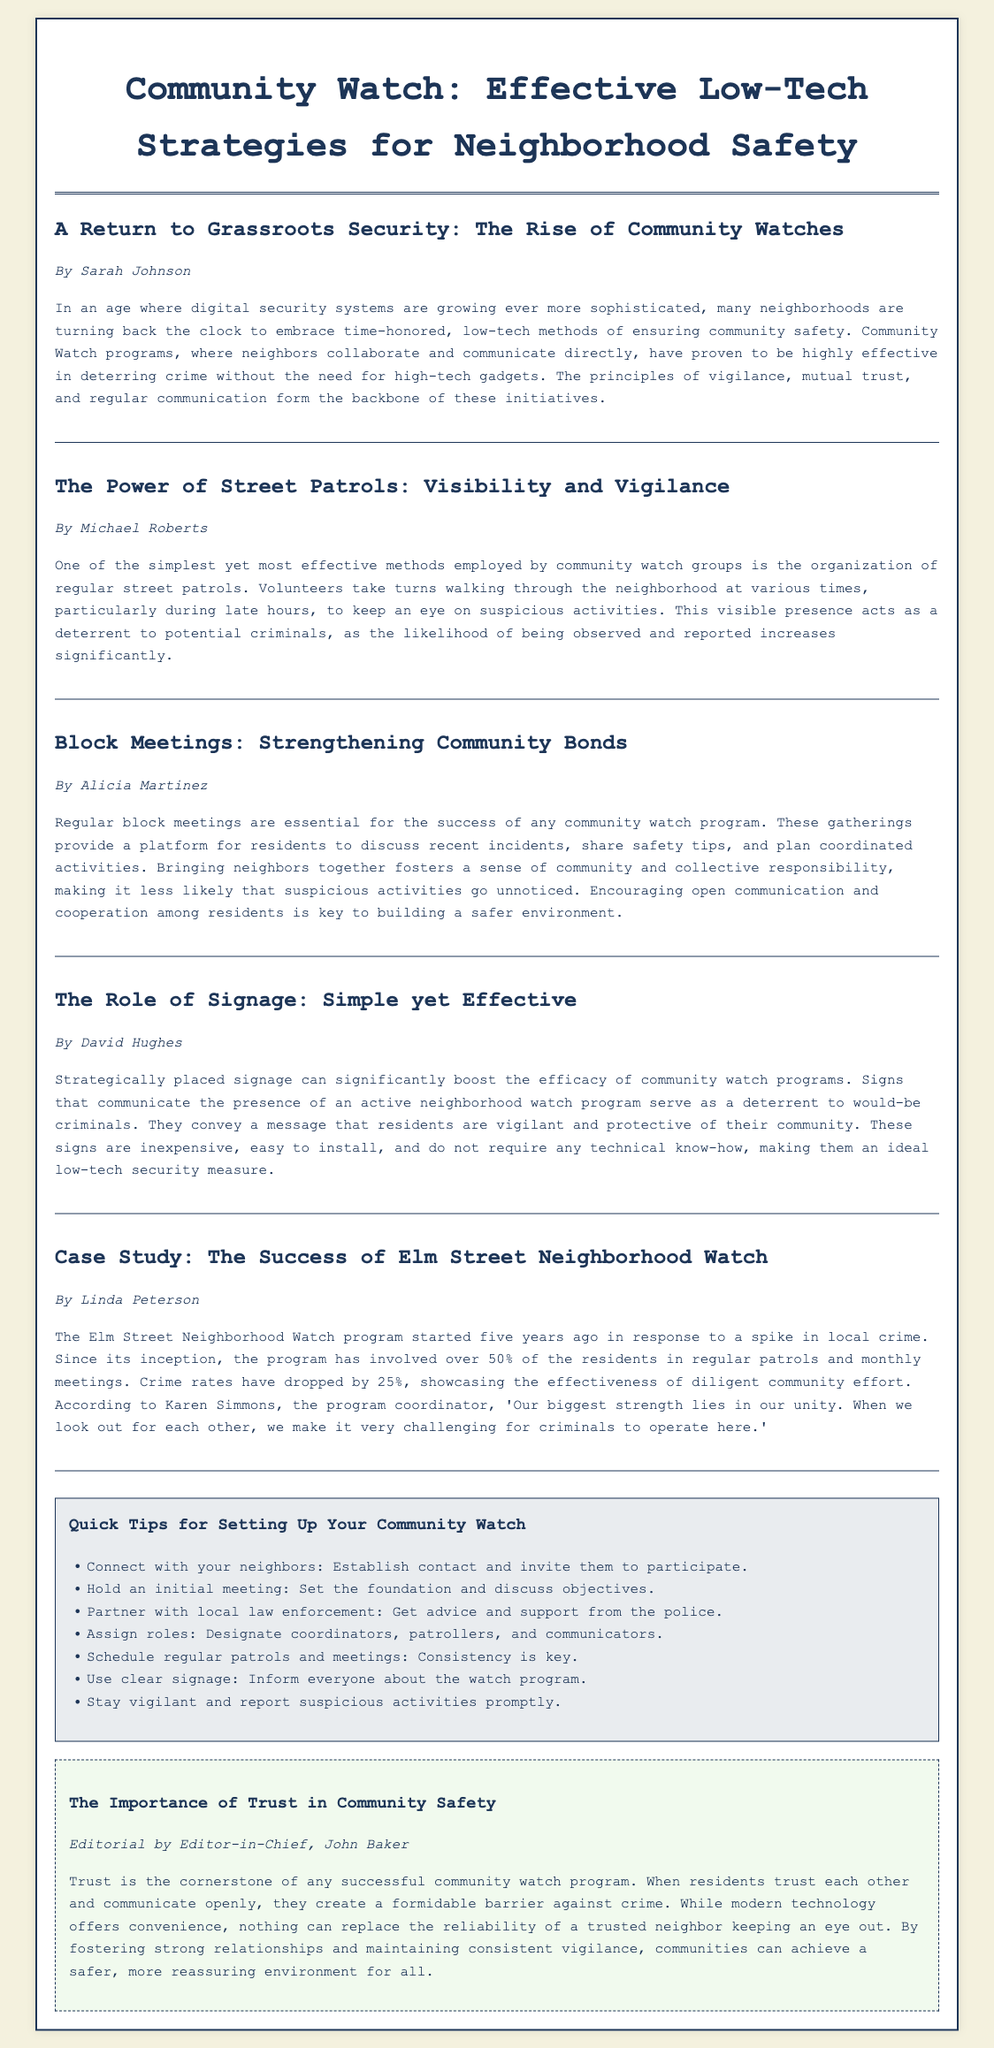what is the main topic of the article? The main topic is focused on low-tech strategies for enhancing neighborhood safety through community watch programs.
Answer: Community Watch: Effective Low-Tech Strategies for Neighborhood Safety who authored the article on street patrols? The article discussing street patrols is written by Michael Roberts.
Answer: Michael Roberts how much did crime rates drop in the Elm Street Neighborhood Watch program? The crime rates dropped by 25% since the program started.
Answer: 25% what is the recommended frequency for block meetings? Regular block meetings are essential for the success of any community watch program, though a specific frequency is not mentioned.
Answer: Regularly what is the significance of signage in community watch programs? Signage communicates the presence of an active neighborhood watch program and serves as a deterrent to criminals.
Answer: A deterrent how many residents have been involved in the Elm Street Neighborhood Watch program? Over 50% of the residents have been involved in the program's activities.
Answer: Over 50% what type of document structure does the article follow? The article follows a newspaper layout structure, including a header, main articles, a sidebar, and an editorial.
Answer: Newspaper layout what are block meetings designed to do? Block meetings are designed to foster communication, discuss incidents, and plan coordinated activities among neighbors.
Answer: Foster communication who wrote the editorial about trust in community safety? The editorial was written by the Editor-in-Chief, John Baker.
Answer: John Baker 